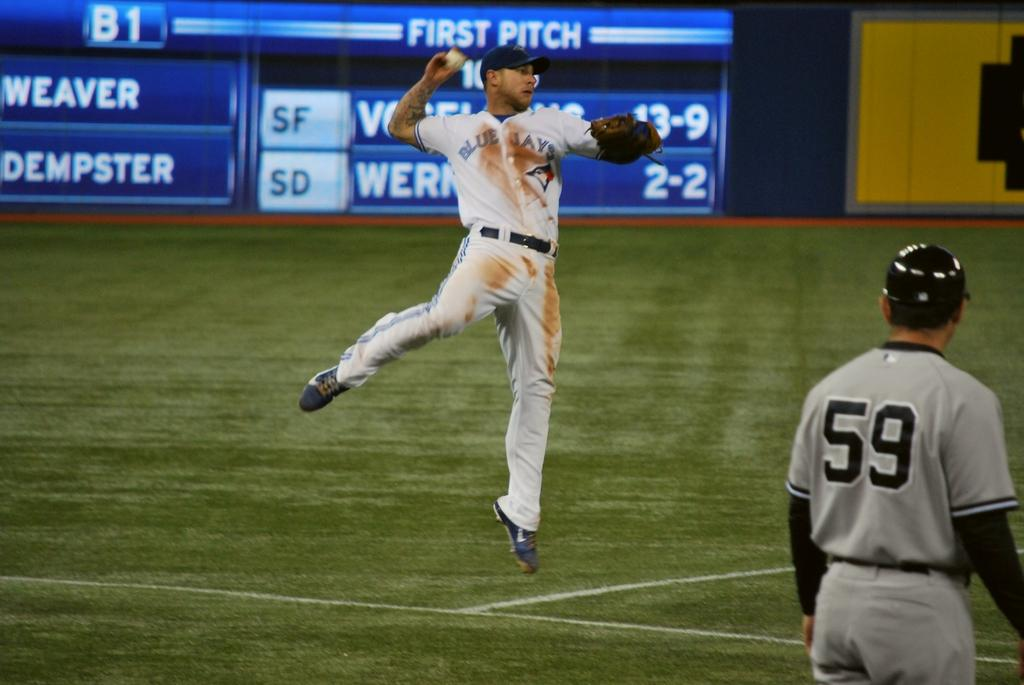<image>
Present a compact description of the photo's key features. A baseball player on a field has a 59 on his jersey. 